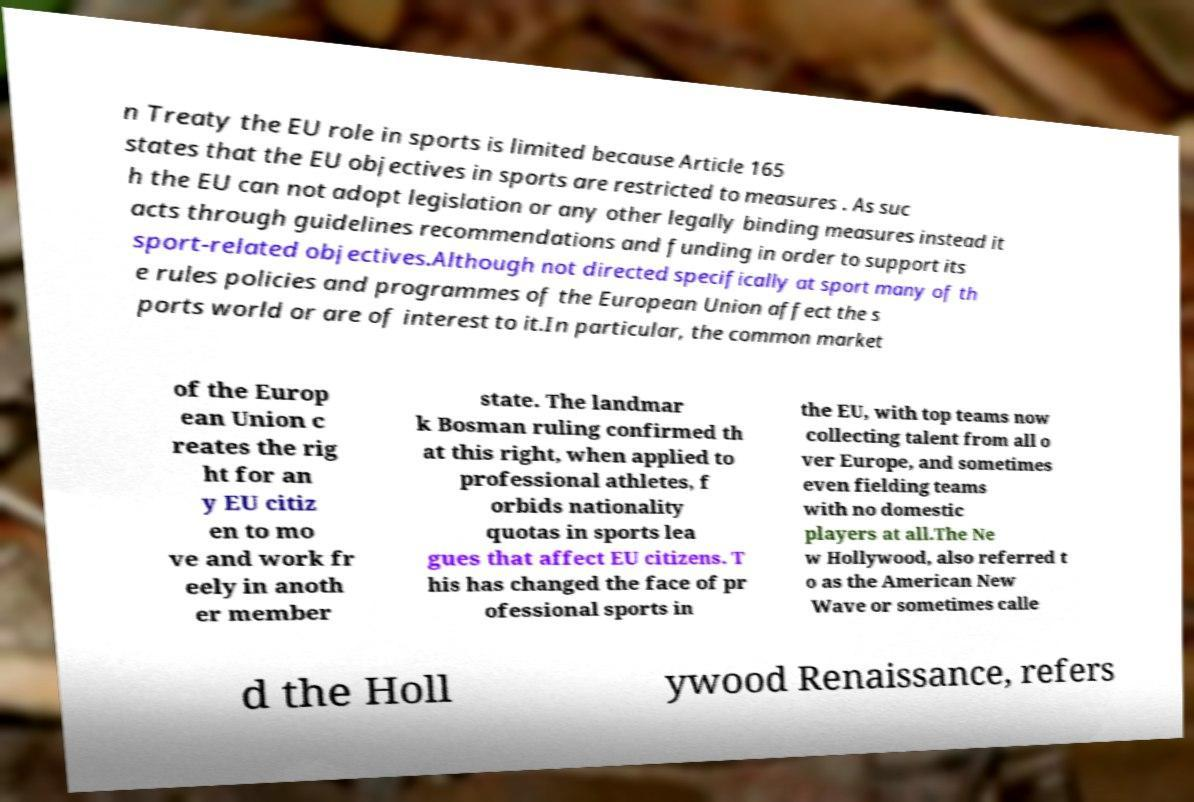Could you extract and type out the text from this image? n Treaty the EU role in sports is limited because Article 165 states that the EU objectives in sports are restricted to measures . As suc h the EU can not adopt legislation or any other legally binding measures instead it acts through guidelines recommendations and funding in order to support its sport-related objectives.Although not directed specifically at sport many of th e rules policies and programmes of the European Union affect the s ports world or are of interest to it.In particular, the common market of the Europ ean Union c reates the rig ht for an y EU citiz en to mo ve and work fr eely in anoth er member state. The landmar k Bosman ruling confirmed th at this right, when applied to professional athletes, f orbids nationality quotas in sports lea gues that affect EU citizens. T his has changed the face of pr ofessional sports in the EU, with top teams now collecting talent from all o ver Europe, and sometimes even fielding teams with no domestic players at all.The Ne w Hollywood, also referred t o as the American New Wave or sometimes calle d the Holl ywood Renaissance, refers 